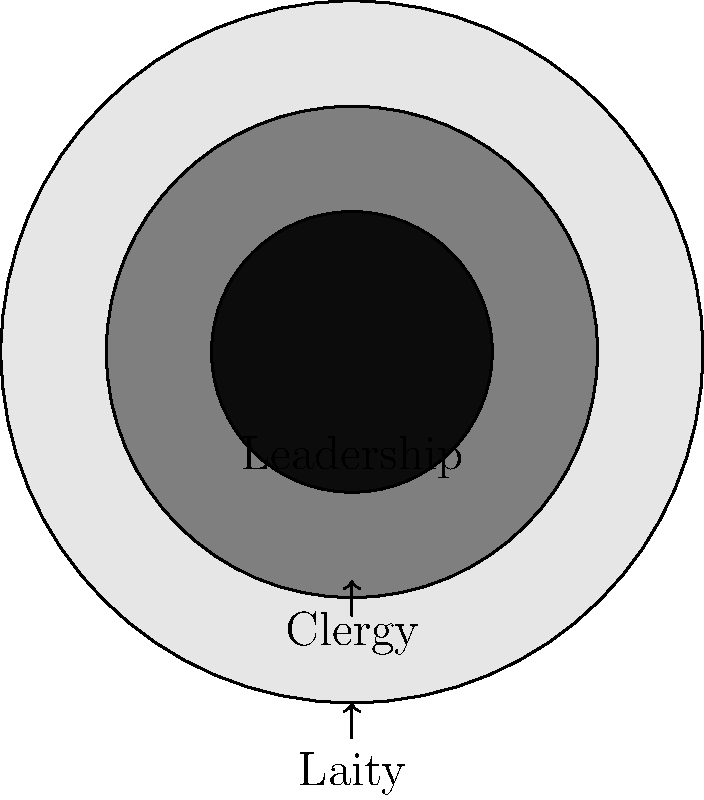In the hierarchical structure of many religious organizations, power and influence often increase as one moves towards the center of decision-making. The nested circles in the diagram represent different levels within a religious organization. If the total area of the diagram represents the entire religious community, what fraction of the community does the leadership (innermost circle) represent, assuming the area of each circle is proportional to the number of people in that level? To solve this problem, we need to follow these steps:

1) Let's denote the radius of the outer circle as $R$, the middle circle as $r$, and the inner circle as $r'$.

2) From the diagram, we can estimate that $r \approx 0.7R$ and $r' \approx 0.4R$.

3) The area of a circle is given by the formula $A = \pi r^2$.

4) The area of the outer circle (total community) is $A_t = \pi R^2$.

5) The area of the inner circle (leadership) is $A_l = \pi (r')^2 = \pi (0.4R)^2 = 0.16\pi R^2$.

6) The fraction of the community represented by the leadership is:

   $\frac{A_l}{A_t} = \frac{0.16\pi R^2}{\pi R^2} = 0.16$

7) This can be simplified to $\frac{4}{25}$ or $16\%$.

This fraction represents the proportion of the total area (and thus, the proportion of the community) that the leadership comprises.
Answer: $\frac{4}{25}$ or $16\%$ 